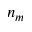Convert formula to latex. <formula><loc_0><loc_0><loc_500><loc_500>n _ { m }</formula> 